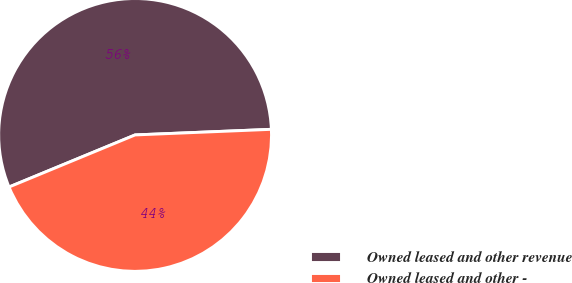<chart> <loc_0><loc_0><loc_500><loc_500><pie_chart><fcel>Owned leased and other revenue<fcel>Owned leased and other -<nl><fcel>55.58%<fcel>44.42%<nl></chart> 